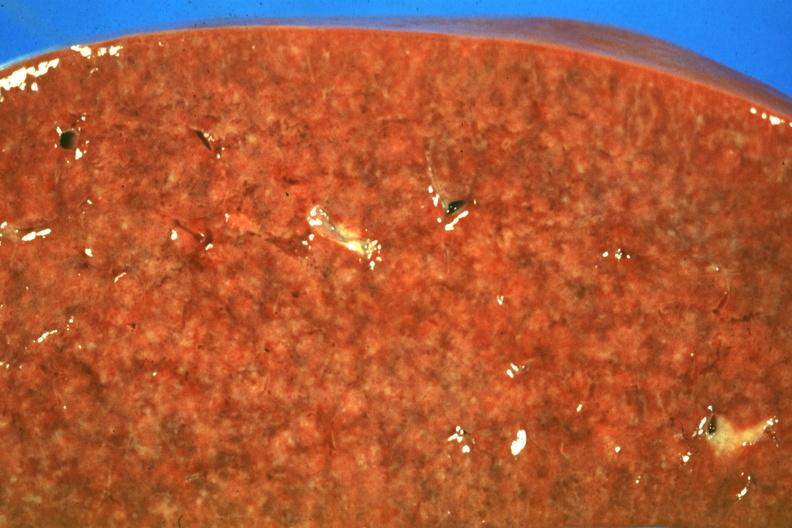s beckwith-wiedemann syndrome present?
Answer the question using a single word or phrase. No 